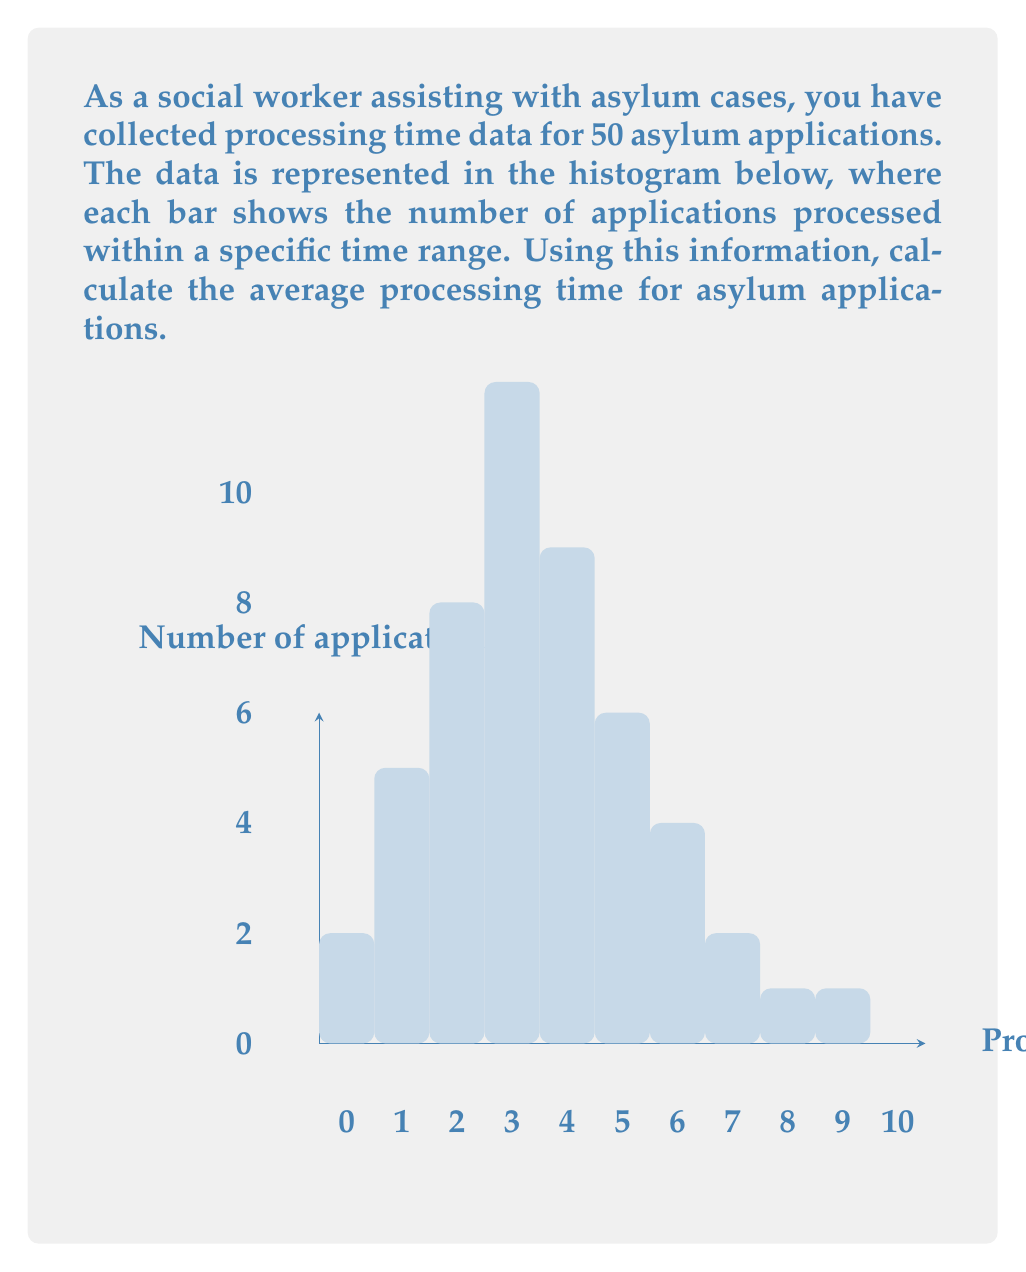Can you solve this math problem? To calculate the average processing time, we need to:

1. Find the midpoint of each time range (class mark)
2. Multiply each midpoint by the number of applications in that range
3. Sum these products
4. Divide by the total number of applications

Let's go through this step-by-step:

1. Midpoints and frequencies:
   0-1 months: midpoint = 0.5, frequency = 2
   1-2 months: midpoint = 1.5, frequency = 5
   2-3 months: midpoint = 2.5, frequency = 8
   3-4 months: midpoint = 3.5, frequency = 12
   4-5 months: midpoint = 4.5, frequency = 9
   5-6 months: midpoint = 5.5, frequency = 6
   6-7 months: midpoint = 6.5, frequency = 4
   7-8 months: midpoint = 7.5, frequency = 2
   8-9 months: midpoint = 8.5, frequency = 1
   9-10 months: midpoint = 9.5, frequency = 1

2. Multiply midpoints by frequencies:
   $0.5 \times 2 = 1$
   $1.5 \times 5 = 7.5$
   $2.5 \times 8 = 20$
   $3.5 \times 12 = 42$
   $4.5 \times 9 = 40.5$
   $5.5 \times 6 = 33$
   $6.5 \times 4 = 26$
   $7.5 \times 2 = 15$
   $8.5 \times 1 = 8.5$
   $9.5 \times 1 = 9.5$

3. Sum of products: $1 + 7.5 + 20 + 42 + 40.5 + 33 + 26 + 15 + 8.5 + 9.5 = 203$

4. Total number of applications: $2 + 5 + 8 + 12 + 9 + 6 + 4 + 2 + 1 + 1 = 50$

5. Calculate average:
   $$\text{Average} = \frac{\text{Sum of products}}{\text{Total applications}} = \frac{203}{50} = 4.06$$

Therefore, the average processing time for asylum applications is 4.06 months.
Answer: 4.06 months 